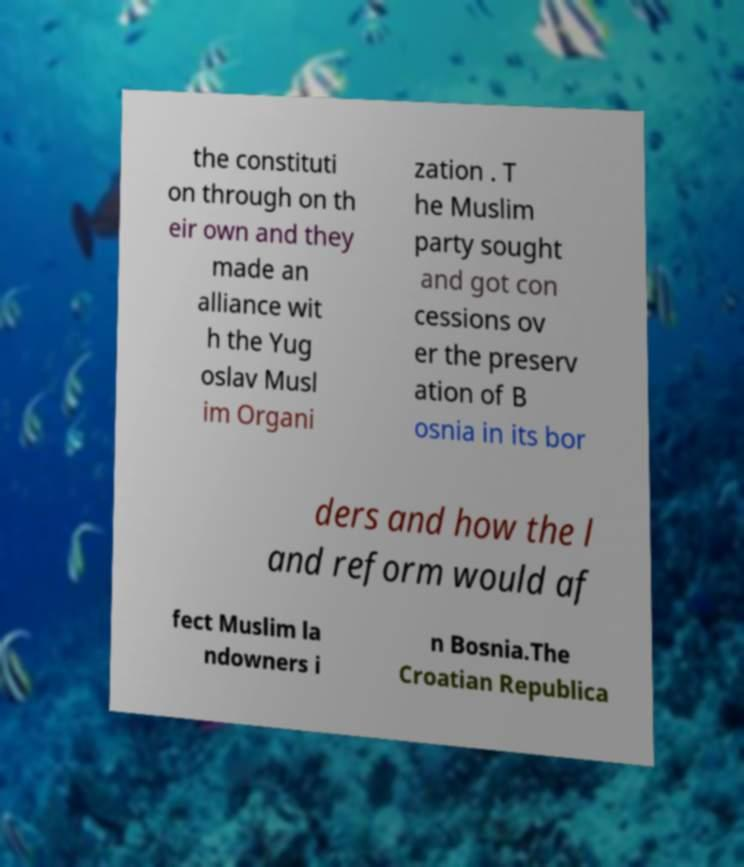What messages or text are displayed in this image? I need them in a readable, typed format. the constituti on through on th eir own and they made an alliance wit h the Yug oslav Musl im Organi zation . T he Muslim party sought and got con cessions ov er the preserv ation of B osnia in its bor ders and how the l and reform would af fect Muslim la ndowners i n Bosnia.The Croatian Republica 